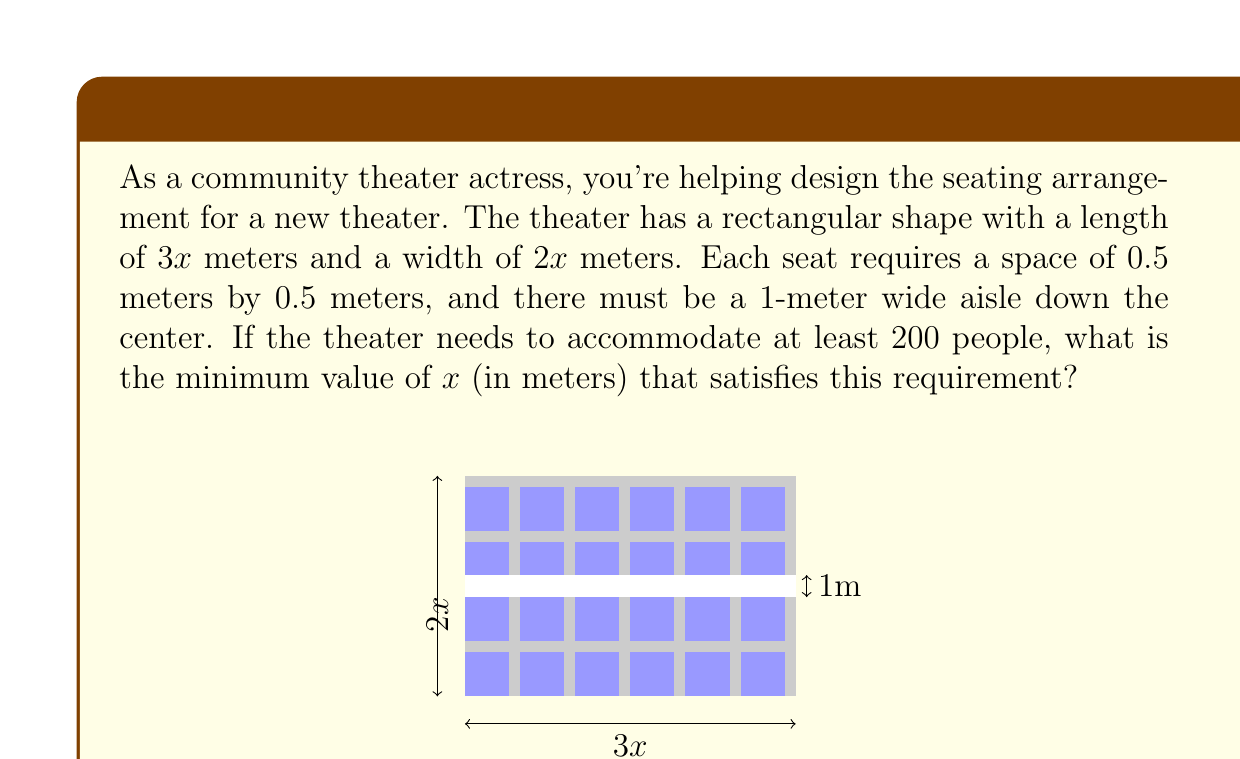Can you solve this math problem? Let's approach this step-by-step:

1) First, we need to calculate the total area of the theater:
   Area = length × width = $3x \times 2x = 6x^2$ square meters

2) Now, we need to subtract the area of the aisle:
   Aisle area = $3x \times 1 = 3x$ square meters
   Remaining area for seats = $6x^2 - 3x$ square meters

3) Each seat requires 0.5m × 0.5m = 0.25 square meters

4) Number of seats = Remaining area ÷ Area per seat
   $$\frac{6x^2 - 3x}{0.25} = 24x^2 - 12x$$

5) We need this to be at least 200:
   $$24x^2 - 12x \geq 200$$

6) Rearranging the inequality:
   $$24x^2 - 12x - 200 \geq 0$$

7) This is a quadratic inequality. We can solve it by finding the roots of the equation:
   $$24x^2 - 12x - 200 = 0$$

8) Using the quadratic formula, $x = \frac{-b \pm \sqrt{b^2 - 4ac}}{2a}$, we get:
   $$x = \frac{12 \pm \sqrt{144 + 19200}}{48} = \frac{12 \pm \sqrt{19344}}{48}$$

9) Simplifying:
   $$x = \frac{12 \pm 139.08}{48}$$

10) This gives us two solutions: $x \approx 3.15$ or $x \approx -2.65$

11) Since length cannot be negative, we take the positive solution.

Therefore, the minimum value of $x$ that satisfies the requirement is approximately 3.15 meters.
Answer: $x \approx 3.15$ meters 